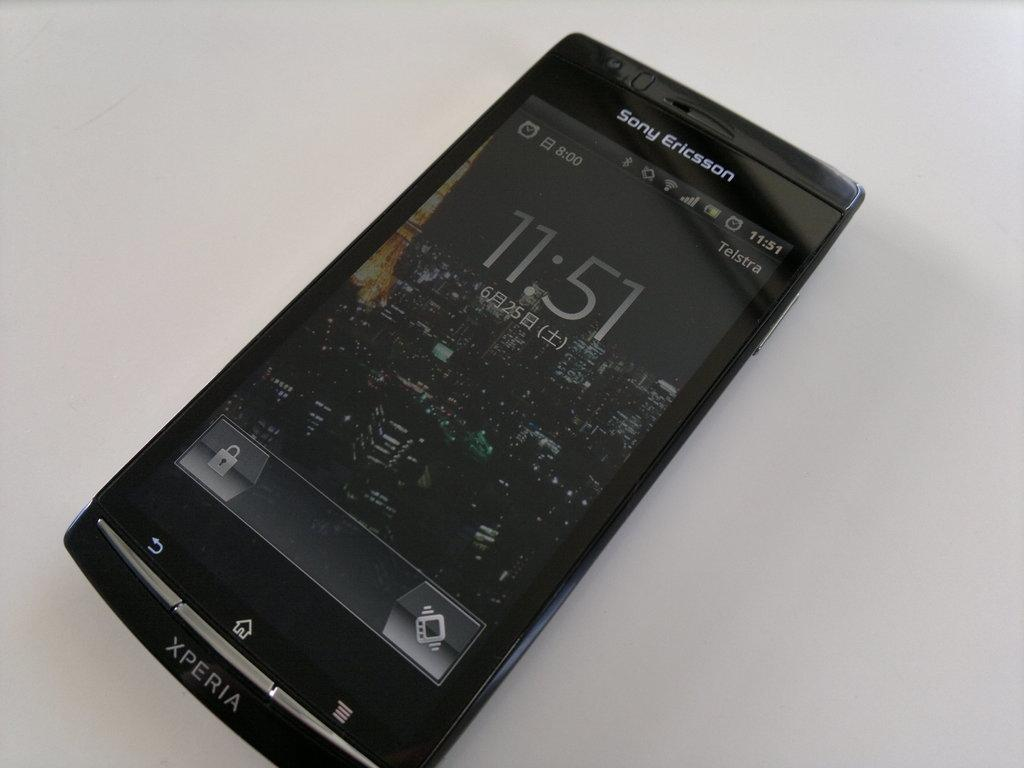<image>
Provide a brief description of the given image. Sony ericsson phone from xperia with the time on the home screen 